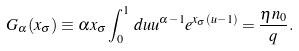Convert formula to latex. <formula><loc_0><loc_0><loc_500><loc_500>G _ { \alpha } ( x _ { \sigma } ) \equiv \alpha x _ { \sigma } \int _ { 0 } ^ { 1 } \, d u u ^ { \alpha - 1 } e ^ { x _ { \sigma } ( u - 1 ) } = \frac { \eta n _ { 0 } } { q } .</formula> 